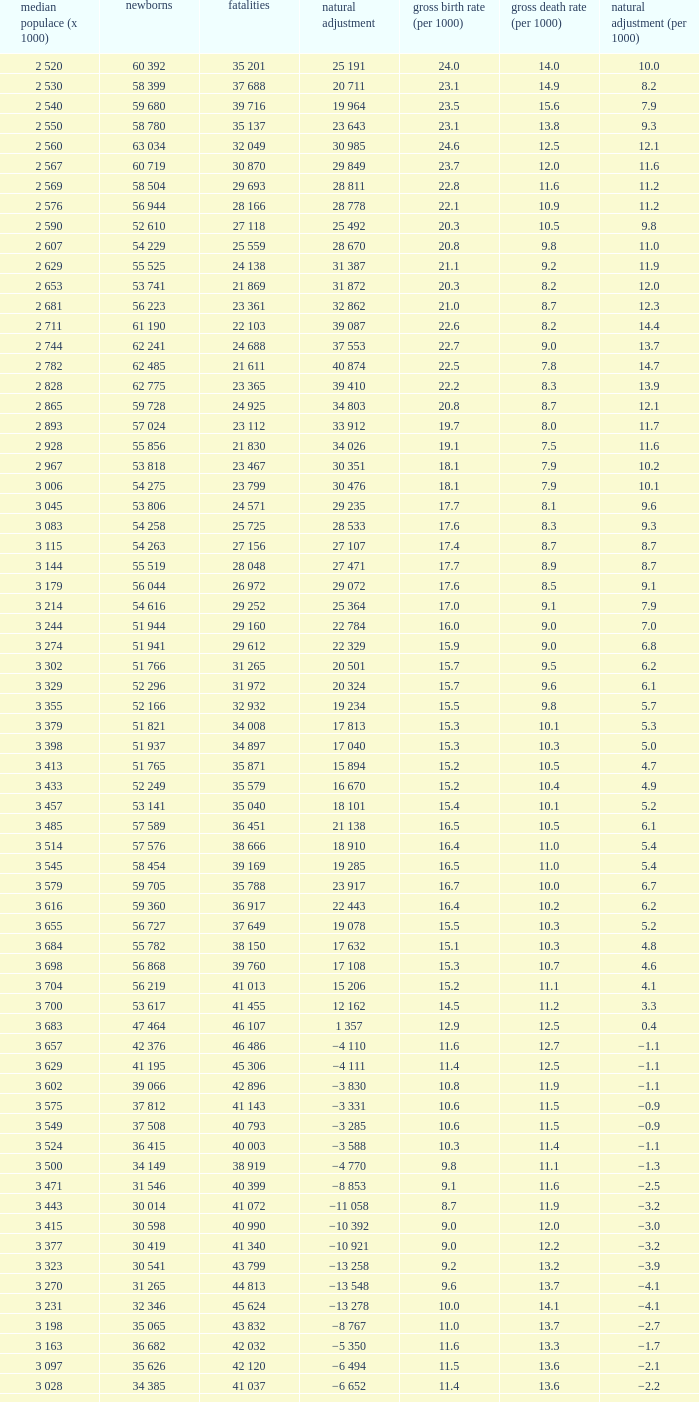Which Natural change has a Crude death rate (per 1000) larger than 9, and Deaths of 40 399? −8 853. 